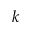<formula> <loc_0><loc_0><loc_500><loc_500>k</formula> 